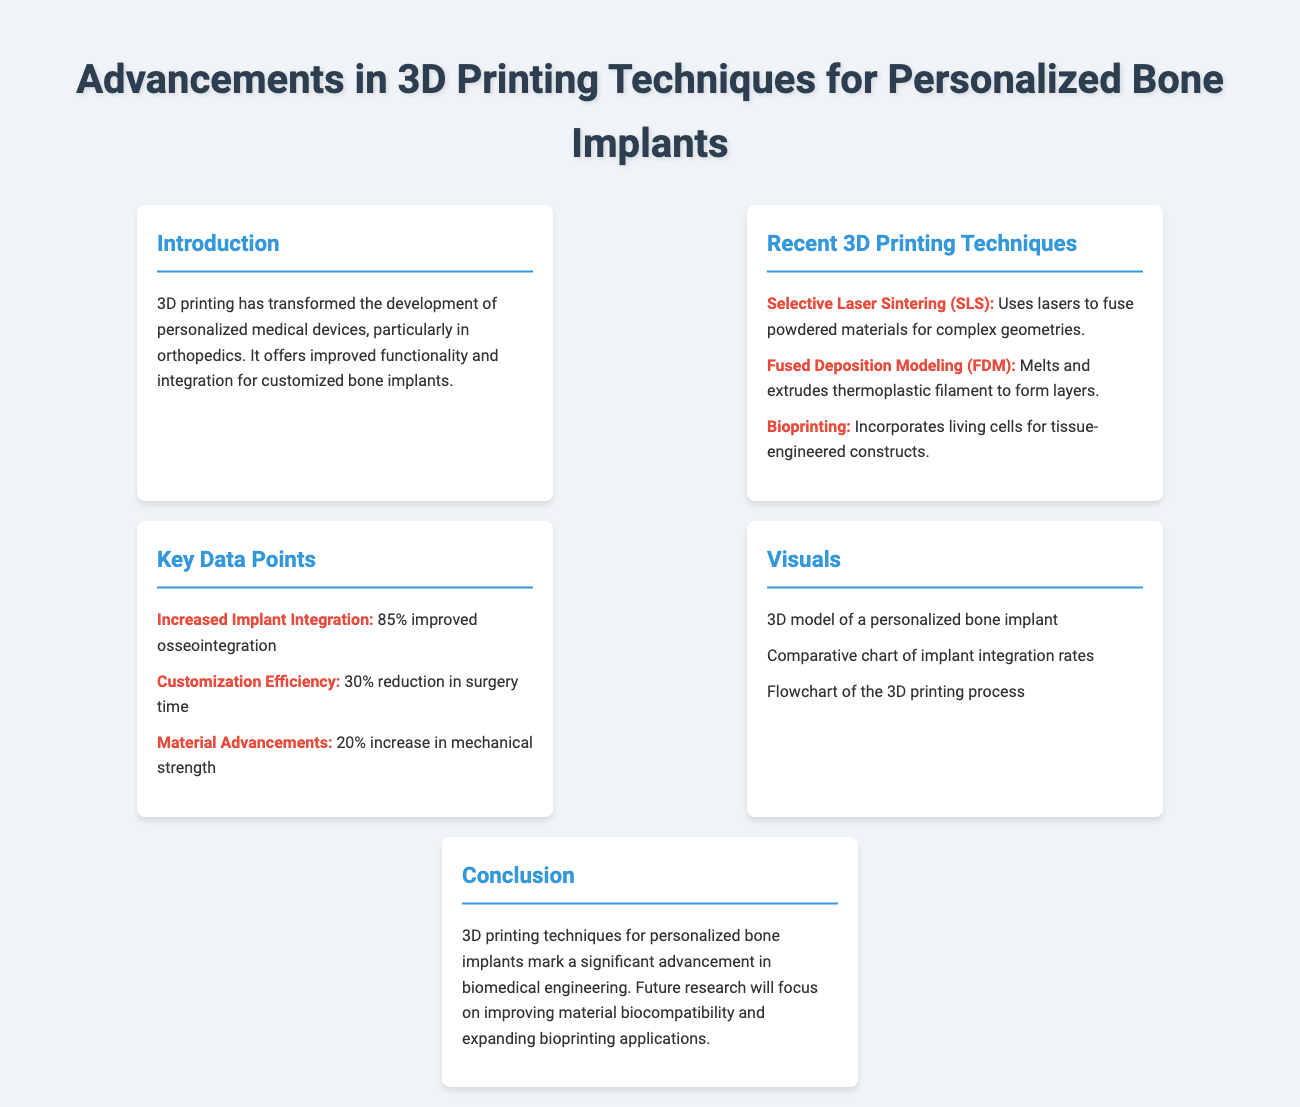What is the main topic of the presentation? The main topic of the presentation is highlighted in the title of the document.
Answer: Advancements in 3D Printing Techniques for Personalized Bone Implants What is one technique used in 3D printing for personalized bone implants? This can be found in the section on recent 3D printing techniques that lists various methods.
Answer: Selective Laser Sintering What percentage improvement in osseointegration is noted? The documented key data point specifies the improvement in implant integration based on recent findings.
Answer: 85% What process is involved in the Fused Deposition Modeling technique? The technique's description provides insight into the manufacturing process of the implant.
Answer: Melts and extrudes thermoplastic filament What visual representation is mentioned in the document? The visuals are listed under the Visuals section, indicating types of images that will be shared.
Answer: 3D model of a personalized bone implant What is the anticipated future research focus mentioned in the conclusion? The conclusion summarizes the future direction for research in this field.
Answer: Improving material biocompatibility How much reduction in surgery time is reported? This crucial data point is shared in the key data points section of the document.
Answer: 30% Which 3D printing technique involves living cells? The description under recent techniques highlights this innovative approach.
Answer: Bioprinting 